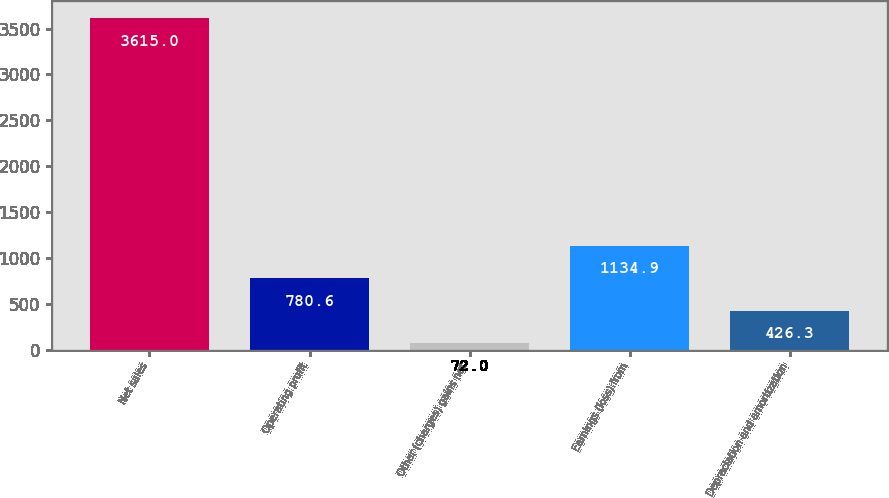Convert chart to OTSL. <chart><loc_0><loc_0><loc_500><loc_500><bar_chart><fcel>Net sales<fcel>Operating profit<fcel>Other (charges) gains net<fcel>Earnings (loss) from<fcel>Depreciation and amortization<nl><fcel>3615<fcel>780.6<fcel>72<fcel>1134.9<fcel>426.3<nl></chart> 